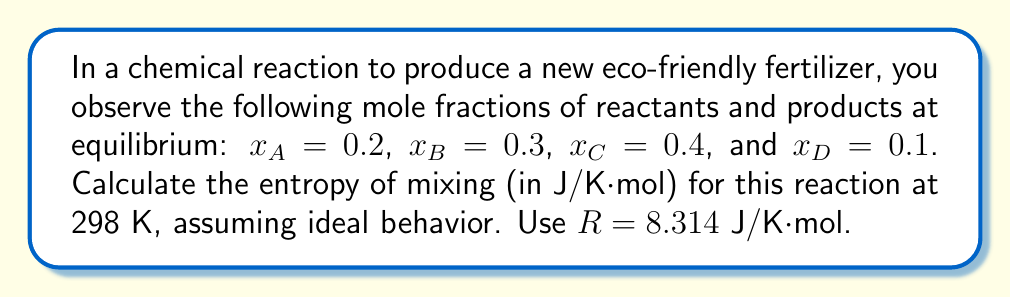Help me with this question. To calculate the entropy of mixing for this chemical reaction, we'll use the formula for the entropy of mixing in an ideal solution:

$$S_{mix} = -R\sum_{i} x_i \ln x_i$$

Where:
- $S_{mix}$ is the entropy of mixing
- $R$ is the gas constant (8.314 J/K·mol)
- $x_i$ is the mole fraction of each component
- $\sum$ represents the sum over all components

Let's substitute the given values:

$$\begin{align}
S_{mix} &= -R(x_A \ln x_A + x_B \ln x_B + x_C \ln x_C + x_D \ln x_D) \\[10pt]
&= -8.314 [(0.2 \ln 0.2) + (0.3 \ln 0.3) + (0.4 \ln 0.4) + (0.1 \ln 0.1)] \\[10pt]
&= -8.314 [(-0.32189) + (-0.36119) + (-0.36651) + (-0.23026)] \\[10pt]
&= -8.314 (-1.27985) \\[10pt]
&= 10.64 \text{ J/K·mol}
\end{align}$$

Note: We use natural logarithms (ln) in this calculation.
Answer: 10.64 J/K·mol 